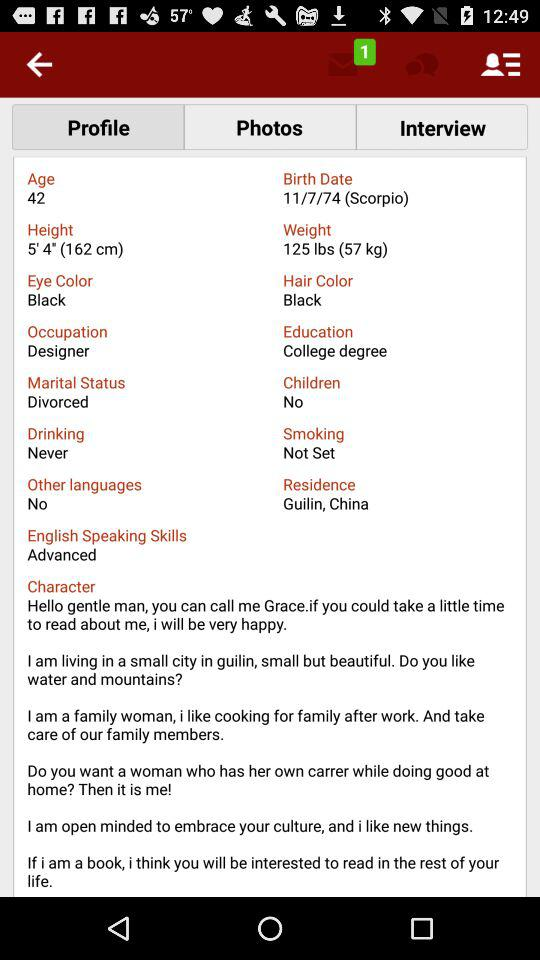How many photos are available in the profile?
When the provided information is insufficient, respond with <no answer>. <no answer> 